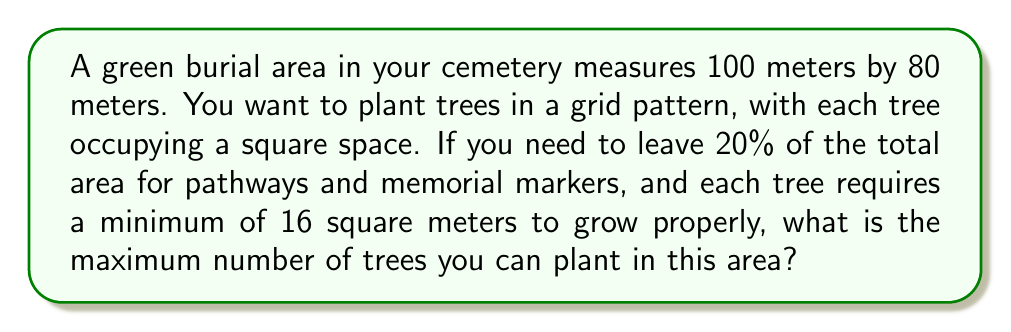What is the answer to this math problem? Let's approach this problem step-by-step:

1) First, calculate the total area of the green burial section:
   $$ \text{Total Area} = 100 \text{ m} \times 80 \text{ m} = 8000 \text{ m}^2 $$

2) Calculate the area available for tree planting after reserving 20% for pathways and markers:
   $$ \text{Available Area} = 80\% \times 8000 \text{ m}^2 = 6400 \text{ m}^2 $$

3) Each tree requires a minimum of 16 square meters. To maximize the number of trees, we'll use this minimum area per tree:
   $$ \text{Area per Tree} = 16 \text{ m}^2 $$

4) Calculate the maximum number of trees by dividing the available area by the area per tree:
   $$ \text{Maximum Trees} = \frac{\text{Available Area}}{\text{Area per Tree}} = \frac{6400 \text{ m}^2}{16 \text{ m}^2} = 400 $$

5) Since we can't plant a fraction of a tree, we round down to the nearest whole number.

Therefore, the maximum number of trees that can be planted is 400.
Answer: 400 trees 